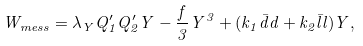<formula> <loc_0><loc_0><loc_500><loc_500>W _ { m e s s } = \lambda _ { Y } Q _ { 1 } ^ { \prime } Q _ { 2 } ^ { \prime } Y - \frac { f } { 3 } Y ^ { 3 } + ( k _ { 1 } \bar { d } d + k _ { 2 } \bar { l } l ) Y ,</formula> 